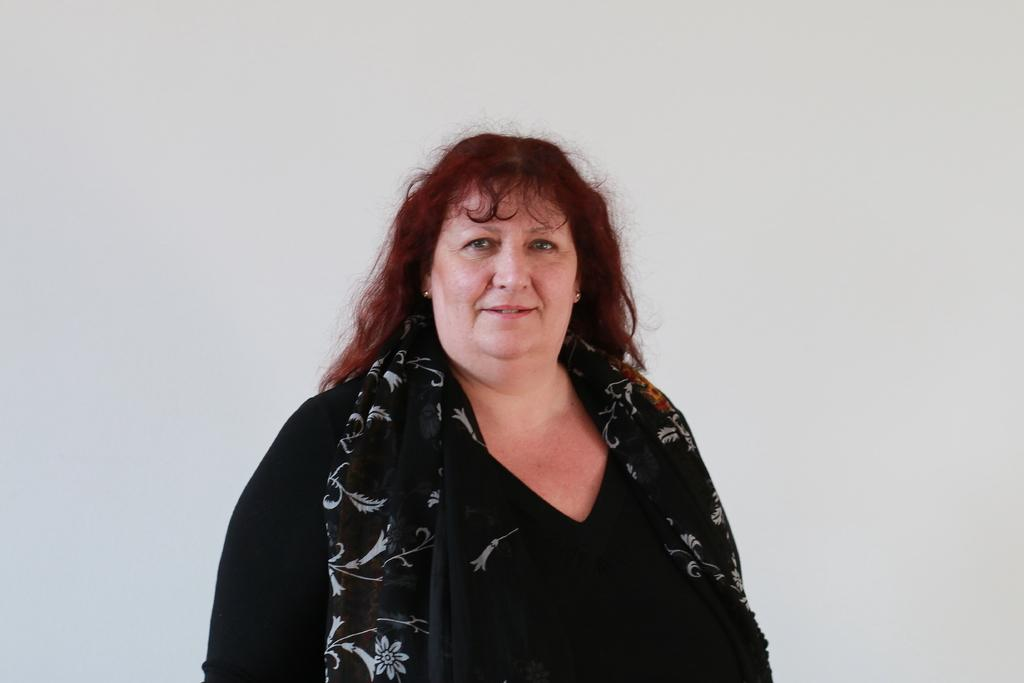Who is the main subject in the image? There is a woman in the center of the image. What is the woman wearing? The woman is wearing a black dress and a scarf. What is the color of the background in the image? The background of the image is white. What type of shock can be seen in the image? There is no shock present in the image; it features a woman wearing a black dress and a scarf against a white background. Is there a chessboard visible in the image? There is no chessboard present in the image. 